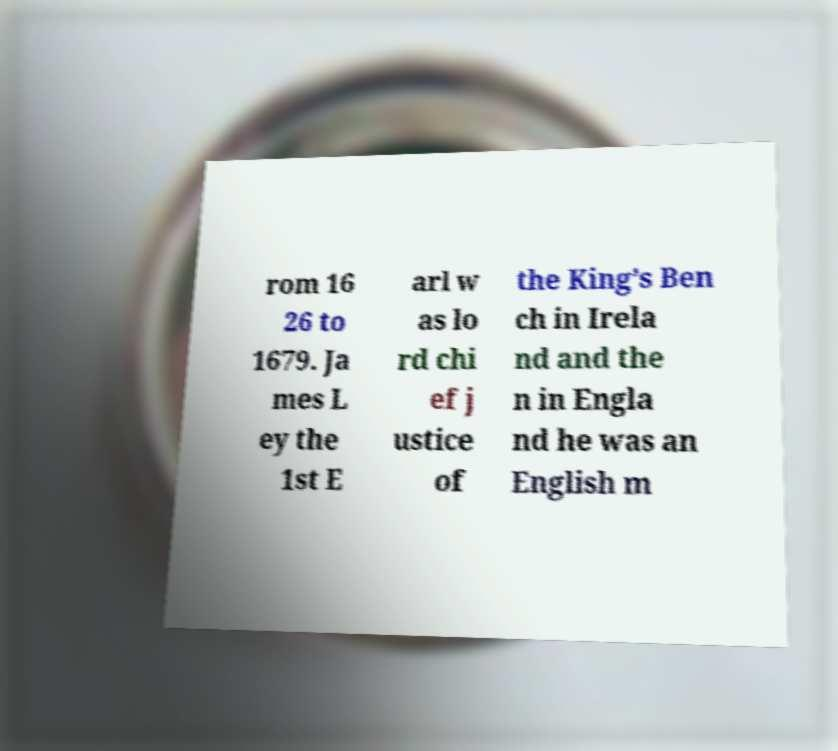What messages or text are displayed in this image? I need them in a readable, typed format. rom 16 26 to 1679. Ja mes L ey the 1st E arl w as lo rd chi ef j ustice of the King’s Ben ch in Irela nd and the n in Engla nd he was an English m 